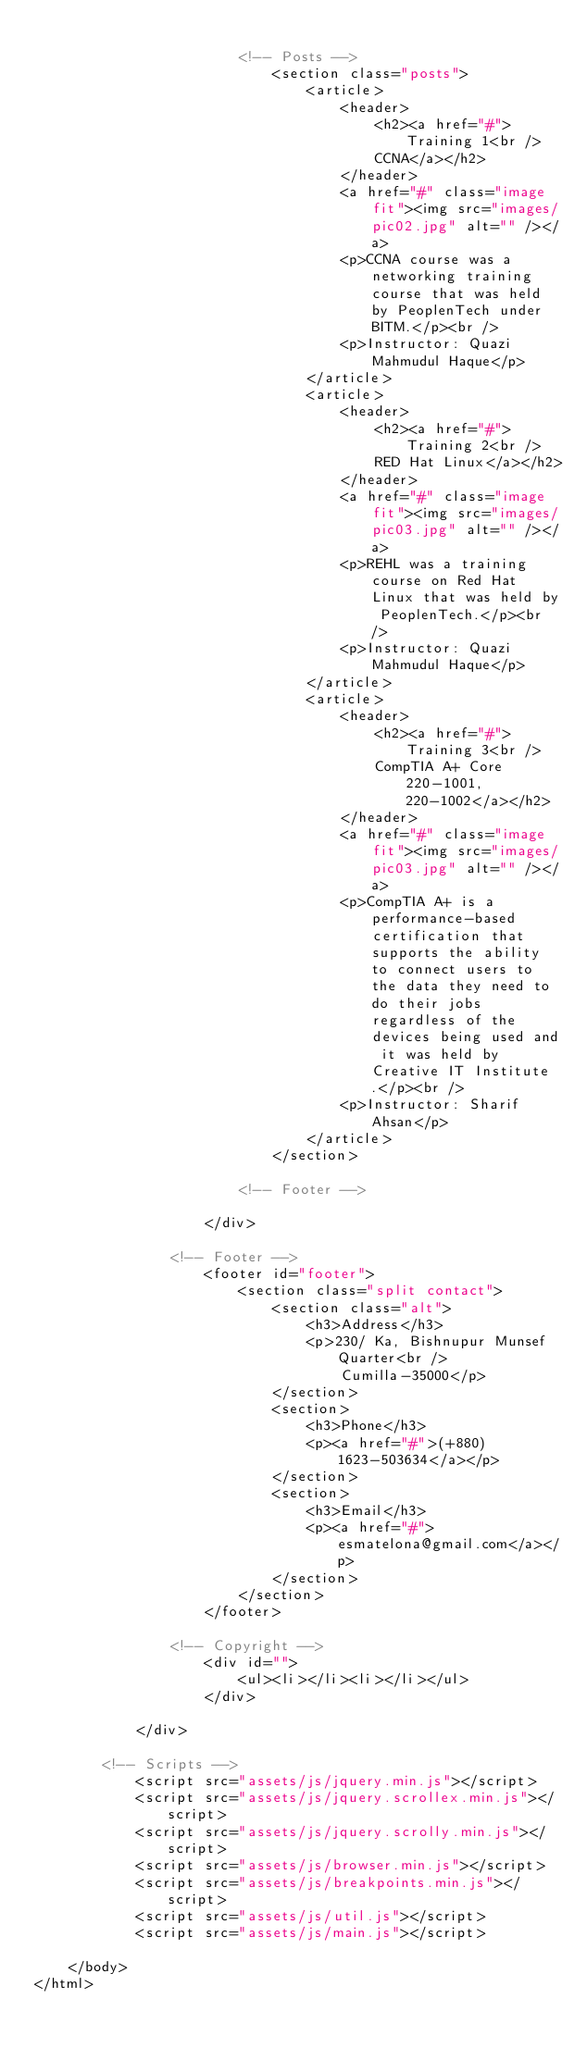<code> <loc_0><loc_0><loc_500><loc_500><_HTML_>
						<!-- Posts -->
							<section class="posts">
								<article>
									<header>
										<h2><a href="#">Training 1<br />
										CCNA</a></h2>
									</header>
									<a href="#" class="image fit"><img src="images/pic02.jpg" alt="" /></a>
									<p>CCNA course was a networking training course that was held by PeoplenTech under BITM.</p><br />
									<p>Instructor: Quazi Mahmudul Haque</p>
								</article>
								<article>
									<header>
										<h2><a href="#">Training 2<br />
										RED Hat Linux</a></h2>
									</header>
									<a href="#" class="image fit"><img src="images/pic03.jpg" alt="" /></a>
									<p>REHL was a training course on Red Hat Linux that was held by PeoplenTech.</p><br />
									<p>Instructor: Quazi Mahmudul Haque</p>
								</article>
								<article>
									<header>
										<h2><a href="#">Training 3<br />
										CompTIA A+ Core 220-1001, 220-1002</a></h2>
									</header>
									<a href="#" class="image fit"><img src="images/pic03.jpg" alt="" /></a>
									<p>CompTIA A+ is a performance-based certification that supports the ability to connect users to the data they need to do their jobs regardless of the devices being used and it was held by Creative IT Institute.</p><br />
									<p>Instructor: Sharif Ahsan</p>
								</article>
							</section>

						<!-- Footer -->

					</div>

				<!-- Footer -->
					<footer id="footer">
						<section class="split contact">
							<section class="alt">
								<h3>Address</h3>
								<p>230/ Ka, Bishnupur Munsef Quarter<br />
									Cumilla-35000</p>
							</section>
							<section>
								<h3>Phone</h3>
								<p><a href="#">(+880) 1623-503634</a></p>
							</section>
							<section>
								<h3>Email</h3>
								<p><a href="#">esmatelona@gmail.com</a></p>
							</section>
						</section>
					</footer>

				<!-- Copyright -->
					<div id="">
						<ul><li></li><li></li></ul>
					</div>

			</div>

		<!-- Scripts -->
			<script src="assets/js/jquery.min.js"></script>
			<script src="assets/js/jquery.scrollex.min.js"></script>
			<script src="assets/js/jquery.scrolly.min.js"></script>
			<script src="assets/js/browser.min.js"></script>
			<script src="assets/js/breakpoints.min.js"></script>
			<script src="assets/js/util.js"></script>
			<script src="assets/js/main.js"></script>

	</body>
</html>
</code> 